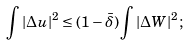Convert formula to latex. <formula><loc_0><loc_0><loc_500><loc_500>\int | \Delta u | ^ { 2 } \leq ( 1 - \bar { \delta } ) \int | \Delta W | ^ { 2 } ;</formula> 